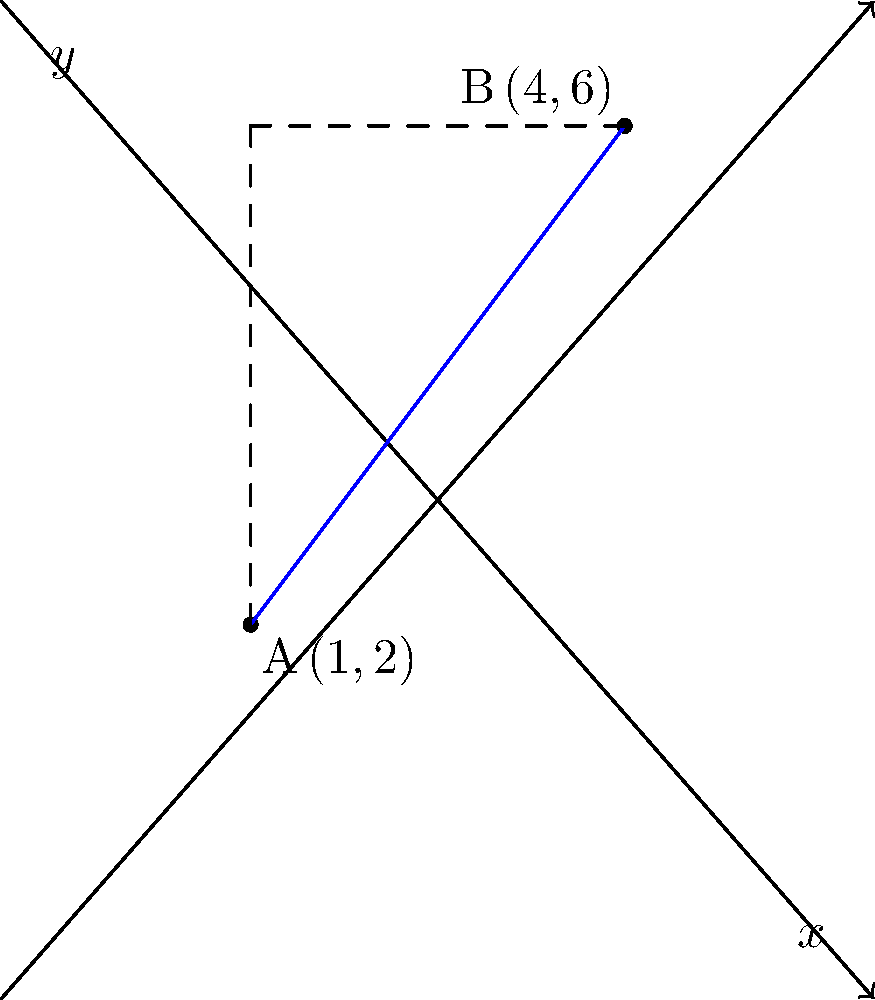As part of a social-emotional learning activity on spatial awareness and problem-solving, you want to help students visualize distance in a coordinate plane. Given two points A(1,2) and B(4,6) on a coordinate plane, calculate the distance between these points using the Pythagorean theorem. How could you use this exercise to foster collaboration and communication skills among your students? To calculate the distance between two points using the Pythagorean theorem, we can follow these steps:

1. Identify the coordinates: A(1,2) and B(4,6)

2. Calculate the difference in x-coordinates:
   $\Delta x = x_2 - x_1 = 4 - 1 = 3$

3. Calculate the difference in y-coordinates:
   $\Delta y = y_2 - y_1 = 6 - 2 = 4$

4. Apply the Pythagorean theorem:
   $d = \sqrt{(\Delta x)^2 + (\Delta y)^2}$

5. Substitute the values:
   $d = \sqrt{3^2 + 4^2}$

6. Simplify:
   $d = \sqrt{9 + 16} = \sqrt{25} = 5$

To foster collaboration and communication skills, you could:
- Divide students into pairs, assigning roles of "explainer" and "listener"
- Have the "explainer" walk through each step while the "listener" provides feedback
- Encourage students to create visual representations of the problem
- Facilitate a class discussion on different problem-solving approaches and how to effectively communicate mathematical concepts
Answer: $5$ units 